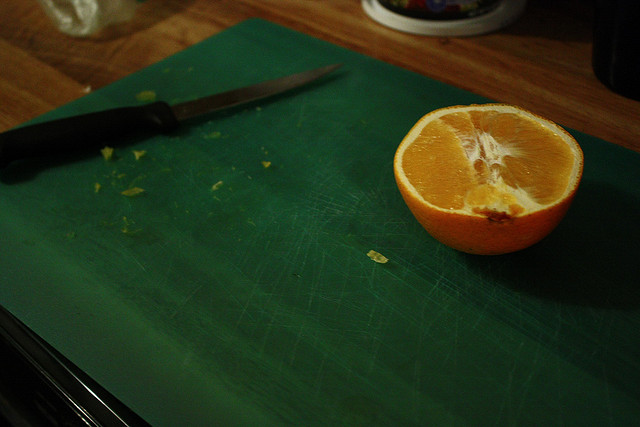Can you tell me more about where Navel oranges are commonly grown? Navel oranges are widely cultivated in the United States, Brazil, and the Mediterranean region, thriving in subtropical climates with warm temperatures and regular rainfall. 